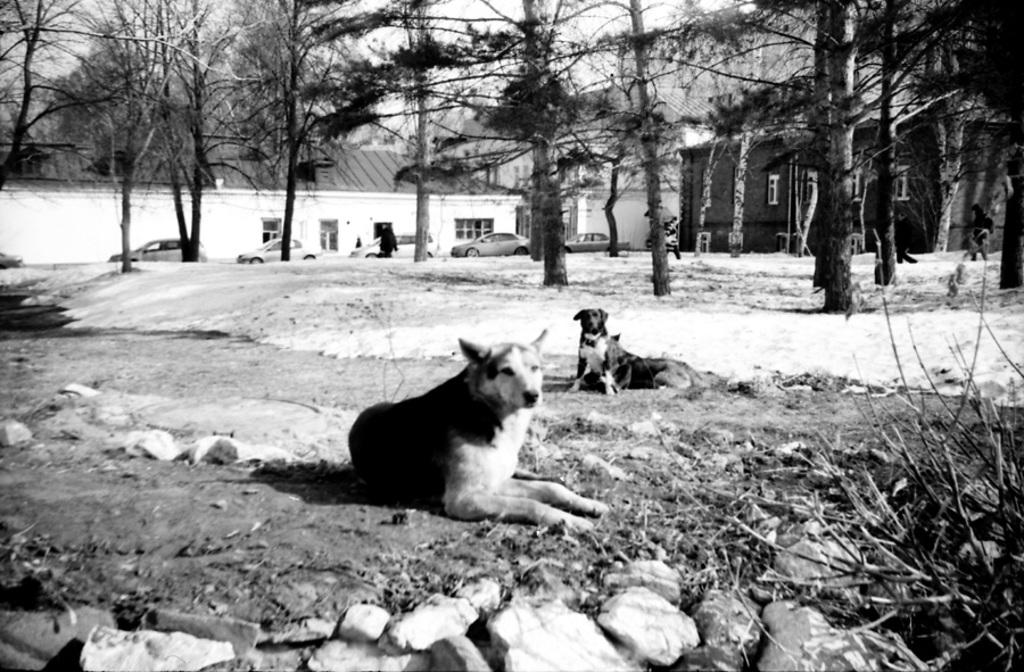What animals are sitting in the image? There are dogs sitting in the image. What can be seen in the background of the image? There are trees, cars, and buildings in the background of the image. What is the color scheme of the image? The image is black and white in color. How does the yarn feel in the image? There is no yarn present in the image, so it cannot be felt or described. 